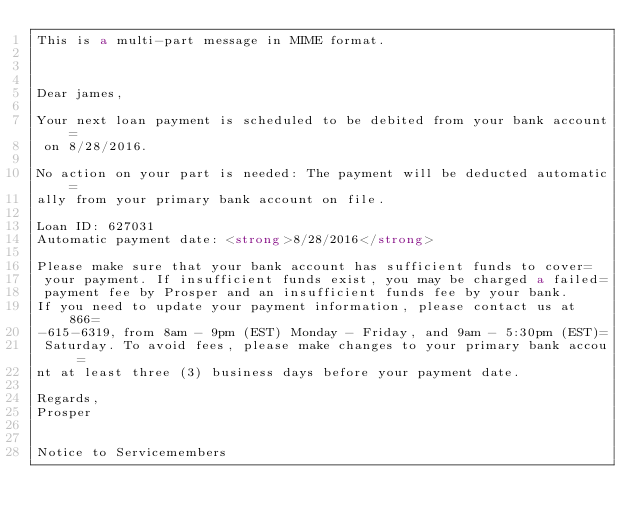Convert code to text. <code><loc_0><loc_0><loc_500><loc_500><_HTML_>This is a multi-part message in MIME format.



Dear james,

Your next loan payment is scheduled to be debited from your bank account=
 on 8/28/2016.

No action on your part is needed: The payment will be deducted automatic=
ally from your primary bank account on file.

Loan ID: 627031
Automatic payment date: <strong>8/28/2016</strong>

Please make sure that your bank account has sufficient funds to cover=
 your payment. If insufficient funds exist, you may be charged a failed=
 payment fee by Prosper and an insufficient funds fee by your bank.
If you need to update your payment information, please contact us at 866=
-615-6319, from 8am - 9pm (EST) Monday - Friday, and 9am - 5:30pm (EST)=
 Saturday. To avoid fees, please make changes to your primary bank accou=
nt at least three (3) business days before your payment date.

Regards,
Prosper


Notice to Servicemembers</code> 